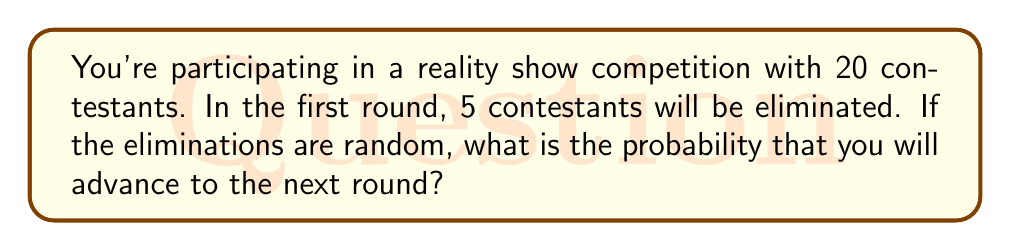Teach me how to tackle this problem. Let's approach this step-by-step:

1) First, we need to understand what the question is asking. We want to find the probability of not being eliminated, which is the same as the probability of advancing to the next round.

2) There are 20 contestants in total, and 5 will be eliminated. This means 15 contestants will advance.

3) To calculate the probability, we use the formula:

   $$ P(\text{advancing}) = \frac{\text{number of favorable outcomes}}{\text{total number of possible outcomes}} $$

4) In this case:
   - The number of favorable outcomes is 15 (the number of contestants who will advance)
   - The total number of possible outcomes is 20 (the total number of contestants)

5) Plugging these numbers into our formula:

   $$ P(\text{advancing}) = \frac{15}{20} $$

6) This fraction can be simplified:

   $$ P(\text{advancing}) = \frac{3}{4} = 0.75 $$

7) We can also express this as a percentage:

   $$ 0.75 \times 100\% = 75\% $$

Therefore, you have a 75% chance of advancing to the next round.
Answer: $\frac{3}{4}$ or $0.75$ or $75\%$ 